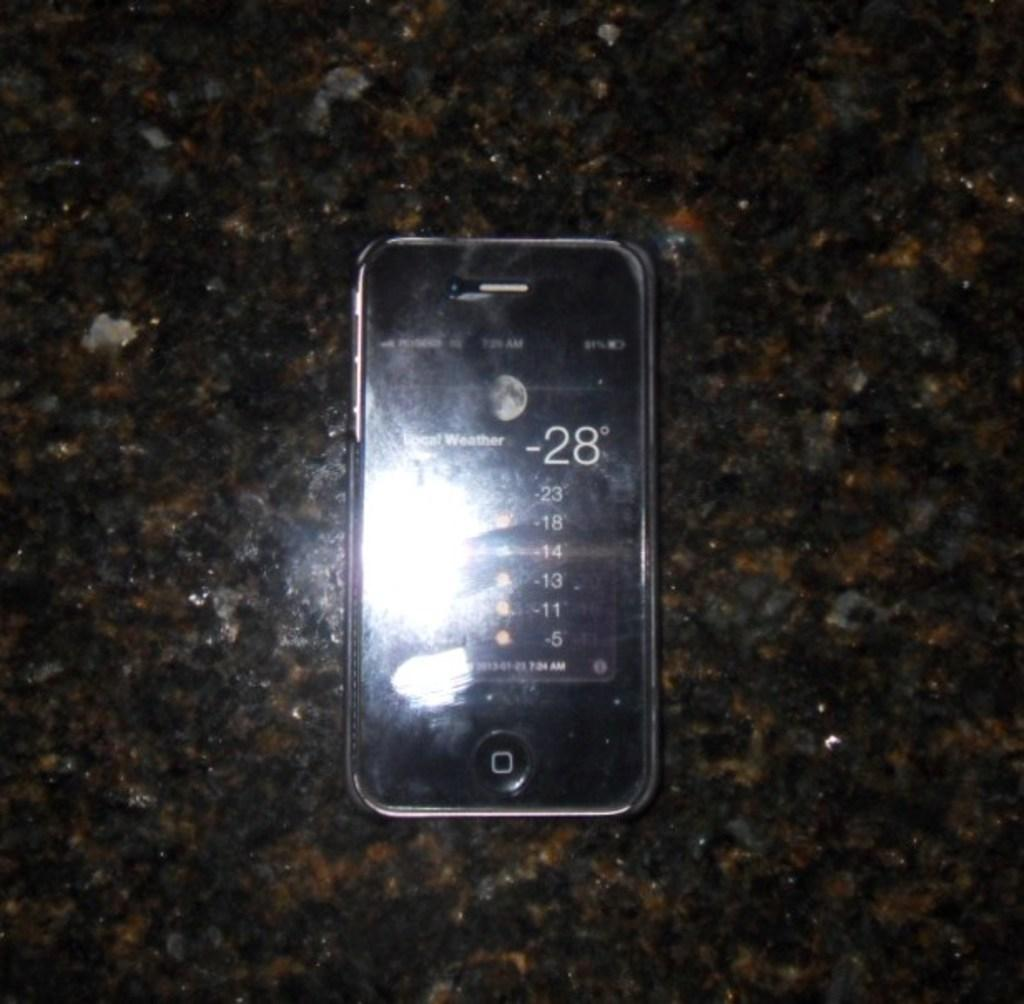Provide a one-sentence caption for the provided image. A smart phone early in the morning on a very cold night. 